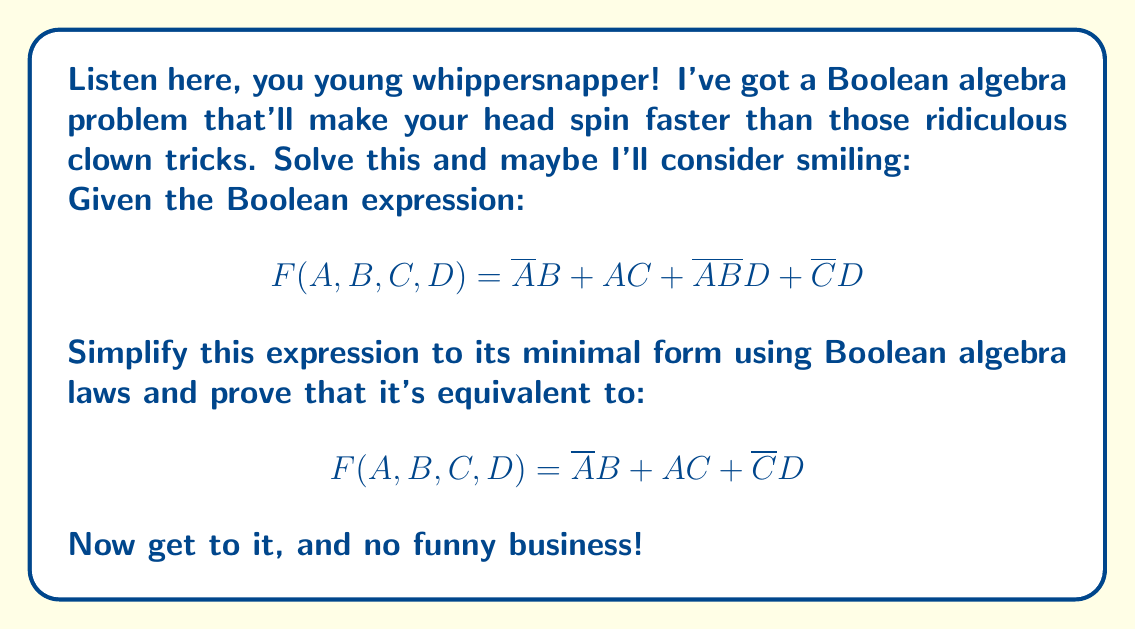Can you solve this math problem? Alright, alright, I'll walk you through this step-by-step. Pay attention now!

1) First, let's look at the original expression:
   $$ F(A,B,C,D) = \overline{A}B + AC + \overline{A}\overline{B}D + \overline{C}D $$

2) We'll start by focusing on the terms containing $\overline{A}$:
   $$ \overline{A}B + \overline{A}\overline{B}D $$

3) We can factor out $\overline{A}$:
   $$ \overline{A}(B + \overline{B}D) $$

4) Now, let's apply the absorption law to $B + \overline{B}D$:
   $$ B + \overline{B}D = B $$
   This is because $B + \overline{B}D = B + (B + \overline{B})D = B + D = B$

5) So now our expression becomes:
   $$ F(A,B,C,D) = \overline{A}B + AC + \overline{C}D $$

6) This is exactly the simplified form we were asked to prove!

To further verify:
- $\overline{A}B$ is already in its simplest form
- $AC$ is already in its simplest form
- $\overline{C}D$ is already in its simplest form

There are no common terms that can be further combined or simplified.
Answer: $$ F(A,B,C,D) = \overline{A}B + AC + \overline{C}D $$ 